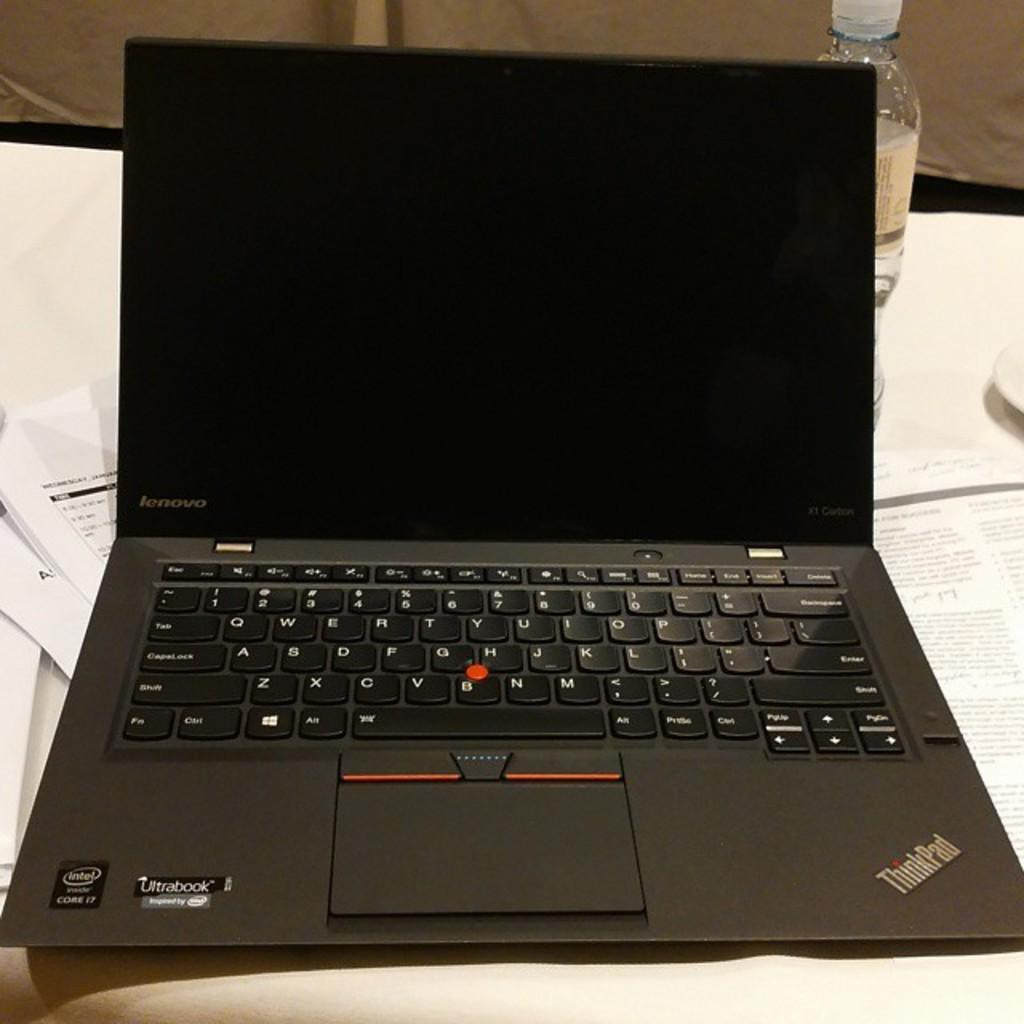<image>
Render a clear and concise summary of the photo. A computer is open with the ThinkPad logo in the corner. 